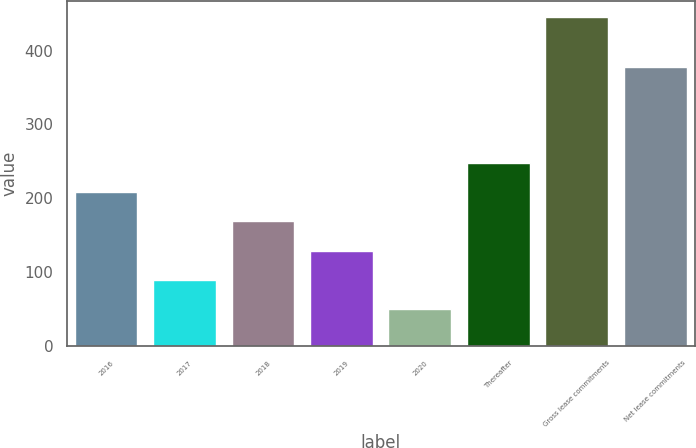Convert chart. <chart><loc_0><loc_0><loc_500><loc_500><bar_chart><fcel>2016<fcel>2017<fcel>2018<fcel>2019<fcel>2020<fcel>Thereafter<fcel>Gross lease commitments<fcel>Net lease commitments<nl><fcel>208.42<fcel>90.13<fcel>168.99<fcel>129.56<fcel>50.7<fcel>247.85<fcel>445<fcel>378<nl></chart> 